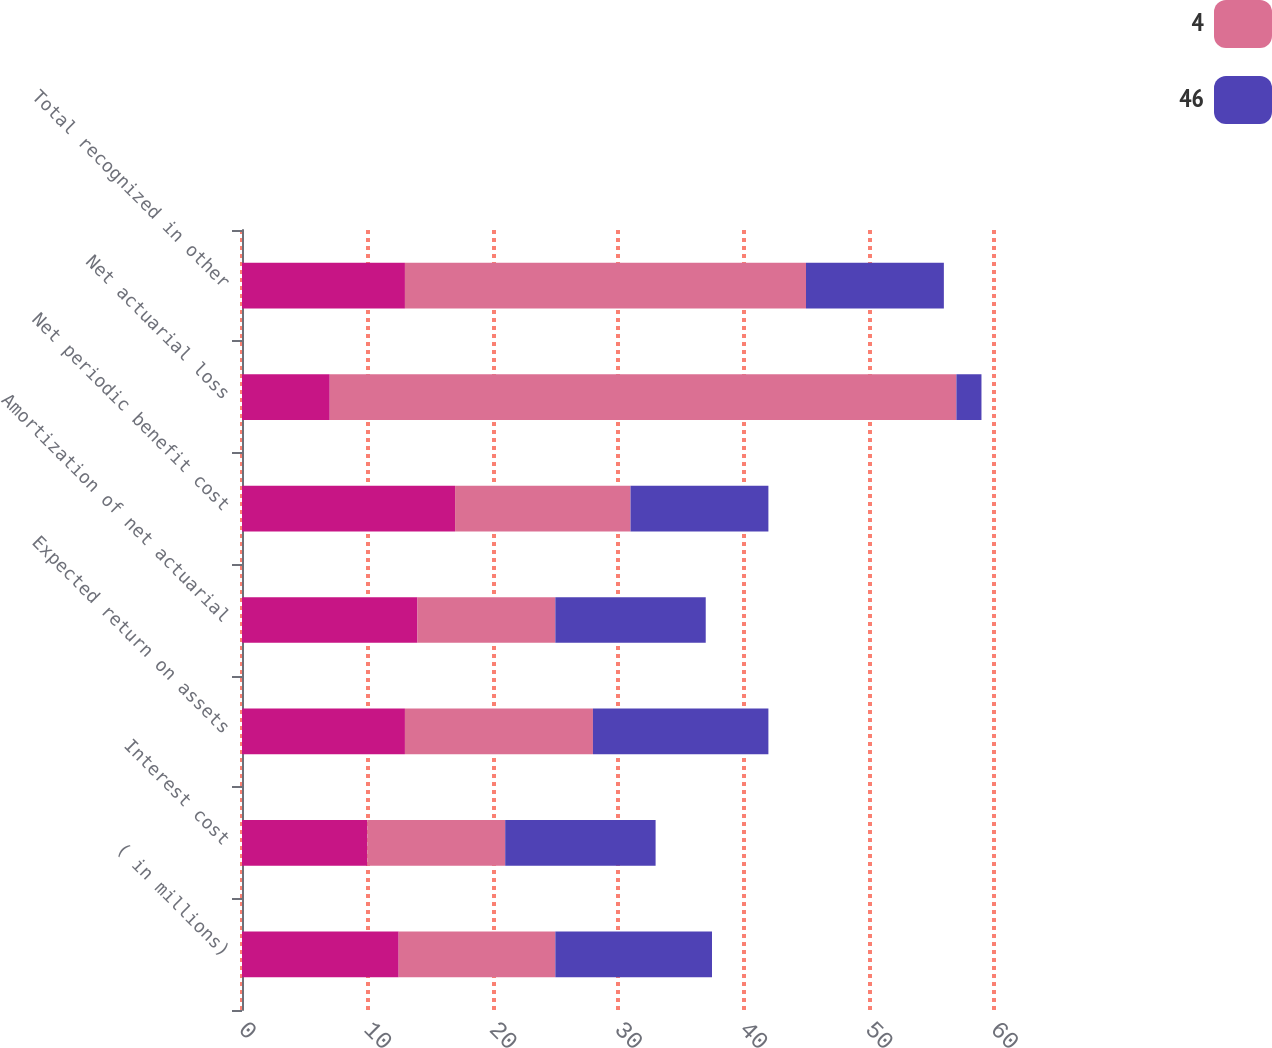Convert chart. <chart><loc_0><loc_0><loc_500><loc_500><stacked_bar_chart><ecel><fcel>( in millions)<fcel>Interest cost<fcel>Expected return on assets<fcel>Amortization of net actuarial<fcel>Net periodic benefit cost<fcel>Net actuarial loss<fcel>Total recognized in other<nl><fcel>nan<fcel>12.5<fcel>10<fcel>13<fcel>14<fcel>17<fcel>7<fcel>13<nl><fcel>4<fcel>12.5<fcel>11<fcel>15<fcel>11<fcel>14<fcel>50<fcel>32<nl><fcel>46<fcel>12.5<fcel>12<fcel>14<fcel>12<fcel>11<fcel>2<fcel>11<nl></chart> 